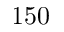<formula> <loc_0><loc_0><loc_500><loc_500>1 5 0</formula> 